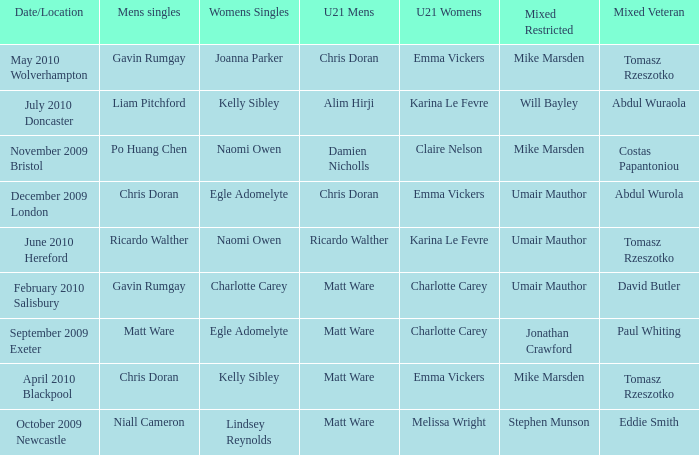When and where did Eddie Smith win the mixed veteran? 1.0. 